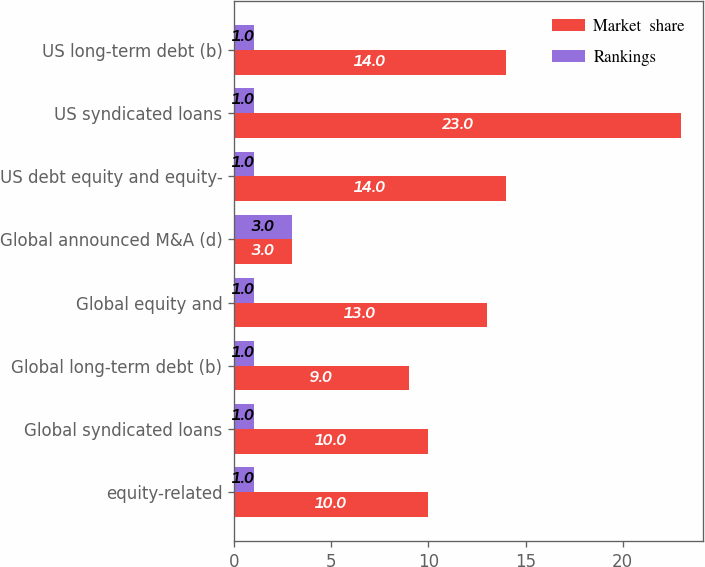Convert chart to OTSL. <chart><loc_0><loc_0><loc_500><loc_500><stacked_bar_chart><ecel><fcel>equity-related<fcel>Global syndicated loans<fcel>Global long-term debt (b)<fcel>Global equity and<fcel>Global announced M&A (d)<fcel>US debt equity and equity-<fcel>US syndicated loans<fcel>US long-term debt (b)<nl><fcel>Market  share<fcel>10<fcel>10<fcel>9<fcel>13<fcel>3<fcel>14<fcel>23<fcel>14<nl><fcel>Rankings<fcel>1<fcel>1<fcel>1<fcel>1<fcel>3<fcel>1<fcel>1<fcel>1<nl></chart> 